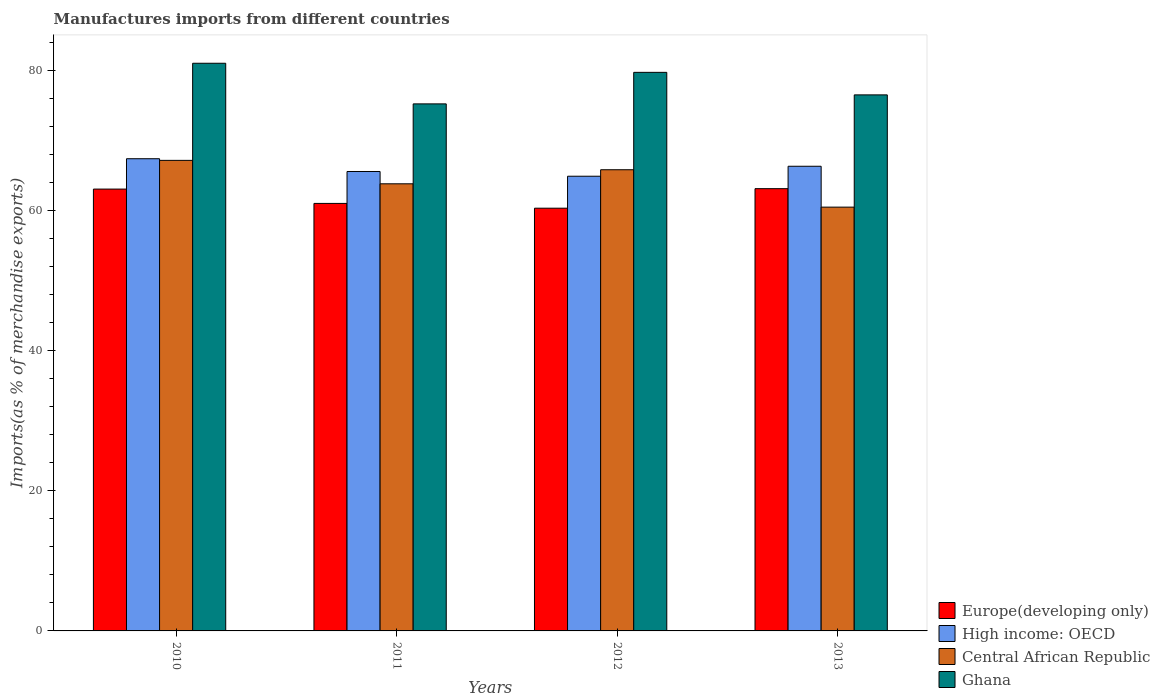How many different coloured bars are there?
Offer a very short reply. 4. How many bars are there on the 2nd tick from the left?
Provide a succinct answer. 4. How many bars are there on the 3rd tick from the right?
Give a very brief answer. 4. In how many cases, is the number of bars for a given year not equal to the number of legend labels?
Your answer should be compact. 0. What is the percentage of imports to different countries in High income: OECD in 2013?
Ensure brevity in your answer.  66.35. Across all years, what is the maximum percentage of imports to different countries in High income: OECD?
Ensure brevity in your answer.  67.43. Across all years, what is the minimum percentage of imports to different countries in High income: OECD?
Make the answer very short. 64.93. In which year was the percentage of imports to different countries in Central African Republic maximum?
Make the answer very short. 2010. In which year was the percentage of imports to different countries in High income: OECD minimum?
Your answer should be very brief. 2012. What is the total percentage of imports to different countries in Ghana in the graph?
Make the answer very short. 312.63. What is the difference between the percentage of imports to different countries in High income: OECD in 2010 and that in 2012?
Offer a terse response. 2.5. What is the difference between the percentage of imports to different countries in Central African Republic in 2012 and the percentage of imports to different countries in High income: OECD in 2013?
Provide a short and direct response. -0.5. What is the average percentage of imports to different countries in Central African Republic per year?
Ensure brevity in your answer.  64.35. In the year 2011, what is the difference between the percentage of imports to different countries in High income: OECD and percentage of imports to different countries in Europe(developing only)?
Keep it short and to the point. 4.56. What is the ratio of the percentage of imports to different countries in Central African Republic in 2010 to that in 2012?
Provide a succinct answer. 1.02. What is the difference between the highest and the second highest percentage of imports to different countries in Central African Republic?
Ensure brevity in your answer.  1.34. What is the difference between the highest and the lowest percentage of imports to different countries in Ghana?
Your answer should be compact. 5.8. What does the 2nd bar from the left in 2011 represents?
Provide a short and direct response. High income: OECD. What does the 3rd bar from the right in 2010 represents?
Keep it short and to the point. High income: OECD. Are all the bars in the graph horizontal?
Provide a short and direct response. No. What is the difference between two consecutive major ticks on the Y-axis?
Make the answer very short. 20. Where does the legend appear in the graph?
Ensure brevity in your answer.  Bottom right. How are the legend labels stacked?
Your answer should be compact. Vertical. What is the title of the graph?
Offer a terse response. Manufactures imports from different countries. What is the label or title of the X-axis?
Your answer should be very brief. Years. What is the label or title of the Y-axis?
Give a very brief answer. Imports(as % of merchandise exports). What is the Imports(as % of merchandise exports) in Europe(developing only) in 2010?
Provide a succinct answer. 63.09. What is the Imports(as % of merchandise exports) of High income: OECD in 2010?
Your answer should be very brief. 67.43. What is the Imports(as % of merchandise exports) in Central African Republic in 2010?
Provide a short and direct response. 67.19. What is the Imports(as % of merchandise exports) in Ghana in 2010?
Your response must be concise. 81.06. What is the Imports(as % of merchandise exports) of Europe(developing only) in 2011?
Give a very brief answer. 61.05. What is the Imports(as % of merchandise exports) in High income: OECD in 2011?
Your response must be concise. 65.6. What is the Imports(as % of merchandise exports) of Central African Republic in 2011?
Offer a very short reply. 63.85. What is the Imports(as % of merchandise exports) of Ghana in 2011?
Give a very brief answer. 75.26. What is the Imports(as % of merchandise exports) of Europe(developing only) in 2012?
Ensure brevity in your answer.  60.36. What is the Imports(as % of merchandise exports) in High income: OECD in 2012?
Give a very brief answer. 64.93. What is the Imports(as % of merchandise exports) of Central African Republic in 2012?
Your response must be concise. 65.86. What is the Imports(as % of merchandise exports) in Ghana in 2012?
Offer a very short reply. 79.76. What is the Imports(as % of merchandise exports) in Europe(developing only) in 2013?
Your answer should be very brief. 63.15. What is the Imports(as % of merchandise exports) in High income: OECD in 2013?
Make the answer very short. 66.35. What is the Imports(as % of merchandise exports) in Central African Republic in 2013?
Make the answer very short. 60.52. What is the Imports(as % of merchandise exports) of Ghana in 2013?
Your answer should be very brief. 76.55. Across all years, what is the maximum Imports(as % of merchandise exports) of Europe(developing only)?
Give a very brief answer. 63.15. Across all years, what is the maximum Imports(as % of merchandise exports) of High income: OECD?
Your answer should be compact. 67.43. Across all years, what is the maximum Imports(as % of merchandise exports) in Central African Republic?
Your answer should be very brief. 67.19. Across all years, what is the maximum Imports(as % of merchandise exports) in Ghana?
Keep it short and to the point. 81.06. Across all years, what is the minimum Imports(as % of merchandise exports) in Europe(developing only)?
Provide a short and direct response. 60.36. Across all years, what is the minimum Imports(as % of merchandise exports) in High income: OECD?
Your answer should be compact. 64.93. Across all years, what is the minimum Imports(as % of merchandise exports) of Central African Republic?
Offer a very short reply. 60.52. Across all years, what is the minimum Imports(as % of merchandise exports) of Ghana?
Provide a succinct answer. 75.26. What is the total Imports(as % of merchandise exports) of Europe(developing only) in the graph?
Offer a terse response. 247.66. What is the total Imports(as % of merchandise exports) of High income: OECD in the graph?
Your answer should be very brief. 264.32. What is the total Imports(as % of merchandise exports) in Central African Republic in the graph?
Your response must be concise. 257.41. What is the total Imports(as % of merchandise exports) of Ghana in the graph?
Make the answer very short. 312.63. What is the difference between the Imports(as % of merchandise exports) in Europe(developing only) in 2010 and that in 2011?
Provide a succinct answer. 2.05. What is the difference between the Imports(as % of merchandise exports) of High income: OECD in 2010 and that in 2011?
Your response must be concise. 1.82. What is the difference between the Imports(as % of merchandise exports) in Central African Republic in 2010 and that in 2011?
Make the answer very short. 3.35. What is the difference between the Imports(as % of merchandise exports) of Ghana in 2010 and that in 2011?
Offer a terse response. 5.8. What is the difference between the Imports(as % of merchandise exports) in Europe(developing only) in 2010 and that in 2012?
Keep it short and to the point. 2.73. What is the difference between the Imports(as % of merchandise exports) of High income: OECD in 2010 and that in 2012?
Offer a terse response. 2.5. What is the difference between the Imports(as % of merchandise exports) in Central African Republic in 2010 and that in 2012?
Offer a very short reply. 1.34. What is the difference between the Imports(as % of merchandise exports) of Ghana in 2010 and that in 2012?
Provide a succinct answer. 1.3. What is the difference between the Imports(as % of merchandise exports) of Europe(developing only) in 2010 and that in 2013?
Your response must be concise. -0.06. What is the difference between the Imports(as % of merchandise exports) in High income: OECD in 2010 and that in 2013?
Your answer should be compact. 1.07. What is the difference between the Imports(as % of merchandise exports) of Central African Republic in 2010 and that in 2013?
Offer a very short reply. 6.68. What is the difference between the Imports(as % of merchandise exports) in Ghana in 2010 and that in 2013?
Provide a short and direct response. 4.52. What is the difference between the Imports(as % of merchandise exports) of Europe(developing only) in 2011 and that in 2012?
Your answer should be compact. 0.68. What is the difference between the Imports(as % of merchandise exports) in High income: OECD in 2011 and that in 2012?
Your answer should be compact. 0.68. What is the difference between the Imports(as % of merchandise exports) of Central African Republic in 2011 and that in 2012?
Make the answer very short. -2.01. What is the difference between the Imports(as % of merchandise exports) of Ghana in 2011 and that in 2012?
Your answer should be compact. -4.5. What is the difference between the Imports(as % of merchandise exports) of Europe(developing only) in 2011 and that in 2013?
Give a very brief answer. -2.1. What is the difference between the Imports(as % of merchandise exports) in High income: OECD in 2011 and that in 2013?
Your answer should be very brief. -0.75. What is the difference between the Imports(as % of merchandise exports) in Central African Republic in 2011 and that in 2013?
Provide a short and direct response. 3.33. What is the difference between the Imports(as % of merchandise exports) of Ghana in 2011 and that in 2013?
Provide a short and direct response. -1.29. What is the difference between the Imports(as % of merchandise exports) of Europe(developing only) in 2012 and that in 2013?
Give a very brief answer. -2.79. What is the difference between the Imports(as % of merchandise exports) of High income: OECD in 2012 and that in 2013?
Provide a short and direct response. -1.42. What is the difference between the Imports(as % of merchandise exports) of Central African Republic in 2012 and that in 2013?
Offer a terse response. 5.34. What is the difference between the Imports(as % of merchandise exports) in Ghana in 2012 and that in 2013?
Provide a succinct answer. 3.22. What is the difference between the Imports(as % of merchandise exports) in Europe(developing only) in 2010 and the Imports(as % of merchandise exports) in High income: OECD in 2011?
Your answer should be compact. -2.51. What is the difference between the Imports(as % of merchandise exports) of Europe(developing only) in 2010 and the Imports(as % of merchandise exports) of Central African Republic in 2011?
Provide a succinct answer. -0.75. What is the difference between the Imports(as % of merchandise exports) of Europe(developing only) in 2010 and the Imports(as % of merchandise exports) of Ghana in 2011?
Give a very brief answer. -12.17. What is the difference between the Imports(as % of merchandise exports) of High income: OECD in 2010 and the Imports(as % of merchandise exports) of Central African Republic in 2011?
Your answer should be very brief. 3.58. What is the difference between the Imports(as % of merchandise exports) of High income: OECD in 2010 and the Imports(as % of merchandise exports) of Ghana in 2011?
Your answer should be compact. -7.83. What is the difference between the Imports(as % of merchandise exports) in Central African Republic in 2010 and the Imports(as % of merchandise exports) in Ghana in 2011?
Give a very brief answer. -8.07. What is the difference between the Imports(as % of merchandise exports) of Europe(developing only) in 2010 and the Imports(as % of merchandise exports) of High income: OECD in 2012?
Offer a very short reply. -1.84. What is the difference between the Imports(as % of merchandise exports) in Europe(developing only) in 2010 and the Imports(as % of merchandise exports) in Central African Republic in 2012?
Offer a terse response. -2.76. What is the difference between the Imports(as % of merchandise exports) in Europe(developing only) in 2010 and the Imports(as % of merchandise exports) in Ghana in 2012?
Offer a very short reply. -16.67. What is the difference between the Imports(as % of merchandise exports) in High income: OECD in 2010 and the Imports(as % of merchandise exports) in Central African Republic in 2012?
Your answer should be very brief. 1.57. What is the difference between the Imports(as % of merchandise exports) of High income: OECD in 2010 and the Imports(as % of merchandise exports) of Ghana in 2012?
Ensure brevity in your answer.  -12.33. What is the difference between the Imports(as % of merchandise exports) in Central African Republic in 2010 and the Imports(as % of merchandise exports) in Ghana in 2012?
Provide a short and direct response. -12.57. What is the difference between the Imports(as % of merchandise exports) of Europe(developing only) in 2010 and the Imports(as % of merchandise exports) of High income: OECD in 2013?
Your answer should be very brief. -3.26. What is the difference between the Imports(as % of merchandise exports) of Europe(developing only) in 2010 and the Imports(as % of merchandise exports) of Central African Republic in 2013?
Offer a terse response. 2.58. What is the difference between the Imports(as % of merchandise exports) of Europe(developing only) in 2010 and the Imports(as % of merchandise exports) of Ghana in 2013?
Give a very brief answer. -13.45. What is the difference between the Imports(as % of merchandise exports) of High income: OECD in 2010 and the Imports(as % of merchandise exports) of Central African Republic in 2013?
Make the answer very short. 6.91. What is the difference between the Imports(as % of merchandise exports) in High income: OECD in 2010 and the Imports(as % of merchandise exports) in Ghana in 2013?
Your answer should be compact. -9.12. What is the difference between the Imports(as % of merchandise exports) of Central African Republic in 2010 and the Imports(as % of merchandise exports) of Ghana in 2013?
Your answer should be very brief. -9.35. What is the difference between the Imports(as % of merchandise exports) in Europe(developing only) in 2011 and the Imports(as % of merchandise exports) in High income: OECD in 2012?
Provide a short and direct response. -3.88. What is the difference between the Imports(as % of merchandise exports) of Europe(developing only) in 2011 and the Imports(as % of merchandise exports) of Central African Republic in 2012?
Give a very brief answer. -4.81. What is the difference between the Imports(as % of merchandise exports) of Europe(developing only) in 2011 and the Imports(as % of merchandise exports) of Ghana in 2012?
Your response must be concise. -18.71. What is the difference between the Imports(as % of merchandise exports) in High income: OECD in 2011 and the Imports(as % of merchandise exports) in Central African Republic in 2012?
Your response must be concise. -0.25. What is the difference between the Imports(as % of merchandise exports) of High income: OECD in 2011 and the Imports(as % of merchandise exports) of Ghana in 2012?
Keep it short and to the point. -14.16. What is the difference between the Imports(as % of merchandise exports) of Central African Republic in 2011 and the Imports(as % of merchandise exports) of Ghana in 2012?
Your answer should be compact. -15.91. What is the difference between the Imports(as % of merchandise exports) of Europe(developing only) in 2011 and the Imports(as % of merchandise exports) of High income: OECD in 2013?
Your answer should be very brief. -5.31. What is the difference between the Imports(as % of merchandise exports) in Europe(developing only) in 2011 and the Imports(as % of merchandise exports) in Central African Republic in 2013?
Provide a succinct answer. 0.53. What is the difference between the Imports(as % of merchandise exports) of Europe(developing only) in 2011 and the Imports(as % of merchandise exports) of Ghana in 2013?
Give a very brief answer. -15.5. What is the difference between the Imports(as % of merchandise exports) of High income: OECD in 2011 and the Imports(as % of merchandise exports) of Central African Republic in 2013?
Your answer should be very brief. 5.09. What is the difference between the Imports(as % of merchandise exports) of High income: OECD in 2011 and the Imports(as % of merchandise exports) of Ghana in 2013?
Provide a succinct answer. -10.94. What is the difference between the Imports(as % of merchandise exports) in Central African Republic in 2011 and the Imports(as % of merchandise exports) in Ghana in 2013?
Give a very brief answer. -12.7. What is the difference between the Imports(as % of merchandise exports) of Europe(developing only) in 2012 and the Imports(as % of merchandise exports) of High income: OECD in 2013?
Give a very brief answer. -5.99. What is the difference between the Imports(as % of merchandise exports) of Europe(developing only) in 2012 and the Imports(as % of merchandise exports) of Central African Republic in 2013?
Provide a short and direct response. -0.15. What is the difference between the Imports(as % of merchandise exports) of Europe(developing only) in 2012 and the Imports(as % of merchandise exports) of Ghana in 2013?
Offer a very short reply. -16.18. What is the difference between the Imports(as % of merchandise exports) of High income: OECD in 2012 and the Imports(as % of merchandise exports) of Central African Republic in 2013?
Make the answer very short. 4.41. What is the difference between the Imports(as % of merchandise exports) in High income: OECD in 2012 and the Imports(as % of merchandise exports) in Ghana in 2013?
Ensure brevity in your answer.  -11.62. What is the difference between the Imports(as % of merchandise exports) of Central African Republic in 2012 and the Imports(as % of merchandise exports) of Ghana in 2013?
Your response must be concise. -10.69. What is the average Imports(as % of merchandise exports) of Europe(developing only) per year?
Keep it short and to the point. 61.91. What is the average Imports(as % of merchandise exports) in High income: OECD per year?
Your answer should be very brief. 66.08. What is the average Imports(as % of merchandise exports) of Central African Republic per year?
Offer a terse response. 64.35. What is the average Imports(as % of merchandise exports) in Ghana per year?
Keep it short and to the point. 78.16. In the year 2010, what is the difference between the Imports(as % of merchandise exports) in Europe(developing only) and Imports(as % of merchandise exports) in High income: OECD?
Offer a very short reply. -4.33. In the year 2010, what is the difference between the Imports(as % of merchandise exports) in Europe(developing only) and Imports(as % of merchandise exports) in Central African Republic?
Give a very brief answer. -4.1. In the year 2010, what is the difference between the Imports(as % of merchandise exports) of Europe(developing only) and Imports(as % of merchandise exports) of Ghana?
Offer a very short reply. -17.97. In the year 2010, what is the difference between the Imports(as % of merchandise exports) in High income: OECD and Imports(as % of merchandise exports) in Central African Republic?
Your response must be concise. 0.23. In the year 2010, what is the difference between the Imports(as % of merchandise exports) of High income: OECD and Imports(as % of merchandise exports) of Ghana?
Your answer should be very brief. -13.63. In the year 2010, what is the difference between the Imports(as % of merchandise exports) in Central African Republic and Imports(as % of merchandise exports) in Ghana?
Give a very brief answer. -13.87. In the year 2011, what is the difference between the Imports(as % of merchandise exports) in Europe(developing only) and Imports(as % of merchandise exports) in High income: OECD?
Ensure brevity in your answer.  -4.56. In the year 2011, what is the difference between the Imports(as % of merchandise exports) in Europe(developing only) and Imports(as % of merchandise exports) in Central African Republic?
Ensure brevity in your answer.  -2.8. In the year 2011, what is the difference between the Imports(as % of merchandise exports) in Europe(developing only) and Imports(as % of merchandise exports) in Ghana?
Provide a succinct answer. -14.21. In the year 2011, what is the difference between the Imports(as % of merchandise exports) of High income: OECD and Imports(as % of merchandise exports) of Central African Republic?
Keep it short and to the point. 1.76. In the year 2011, what is the difference between the Imports(as % of merchandise exports) of High income: OECD and Imports(as % of merchandise exports) of Ghana?
Your answer should be very brief. -9.66. In the year 2011, what is the difference between the Imports(as % of merchandise exports) of Central African Republic and Imports(as % of merchandise exports) of Ghana?
Make the answer very short. -11.41. In the year 2012, what is the difference between the Imports(as % of merchandise exports) of Europe(developing only) and Imports(as % of merchandise exports) of High income: OECD?
Make the answer very short. -4.56. In the year 2012, what is the difference between the Imports(as % of merchandise exports) in Europe(developing only) and Imports(as % of merchandise exports) in Central African Republic?
Your response must be concise. -5.49. In the year 2012, what is the difference between the Imports(as % of merchandise exports) of Europe(developing only) and Imports(as % of merchandise exports) of Ghana?
Your response must be concise. -19.4. In the year 2012, what is the difference between the Imports(as % of merchandise exports) in High income: OECD and Imports(as % of merchandise exports) in Central African Republic?
Keep it short and to the point. -0.93. In the year 2012, what is the difference between the Imports(as % of merchandise exports) of High income: OECD and Imports(as % of merchandise exports) of Ghana?
Ensure brevity in your answer.  -14.83. In the year 2012, what is the difference between the Imports(as % of merchandise exports) in Central African Republic and Imports(as % of merchandise exports) in Ghana?
Your response must be concise. -13.91. In the year 2013, what is the difference between the Imports(as % of merchandise exports) of Europe(developing only) and Imports(as % of merchandise exports) of High income: OECD?
Offer a very short reply. -3.2. In the year 2013, what is the difference between the Imports(as % of merchandise exports) in Europe(developing only) and Imports(as % of merchandise exports) in Central African Republic?
Your answer should be very brief. 2.64. In the year 2013, what is the difference between the Imports(as % of merchandise exports) of Europe(developing only) and Imports(as % of merchandise exports) of Ghana?
Provide a short and direct response. -13.39. In the year 2013, what is the difference between the Imports(as % of merchandise exports) of High income: OECD and Imports(as % of merchandise exports) of Central African Republic?
Make the answer very short. 5.84. In the year 2013, what is the difference between the Imports(as % of merchandise exports) of High income: OECD and Imports(as % of merchandise exports) of Ghana?
Your response must be concise. -10.19. In the year 2013, what is the difference between the Imports(as % of merchandise exports) of Central African Republic and Imports(as % of merchandise exports) of Ghana?
Provide a succinct answer. -16.03. What is the ratio of the Imports(as % of merchandise exports) in Europe(developing only) in 2010 to that in 2011?
Offer a very short reply. 1.03. What is the ratio of the Imports(as % of merchandise exports) of High income: OECD in 2010 to that in 2011?
Provide a succinct answer. 1.03. What is the ratio of the Imports(as % of merchandise exports) in Central African Republic in 2010 to that in 2011?
Keep it short and to the point. 1.05. What is the ratio of the Imports(as % of merchandise exports) in Ghana in 2010 to that in 2011?
Keep it short and to the point. 1.08. What is the ratio of the Imports(as % of merchandise exports) in Europe(developing only) in 2010 to that in 2012?
Offer a terse response. 1.05. What is the ratio of the Imports(as % of merchandise exports) of Central African Republic in 2010 to that in 2012?
Offer a terse response. 1.02. What is the ratio of the Imports(as % of merchandise exports) of Ghana in 2010 to that in 2012?
Make the answer very short. 1.02. What is the ratio of the Imports(as % of merchandise exports) of High income: OECD in 2010 to that in 2013?
Offer a terse response. 1.02. What is the ratio of the Imports(as % of merchandise exports) of Central African Republic in 2010 to that in 2013?
Your response must be concise. 1.11. What is the ratio of the Imports(as % of merchandise exports) of Ghana in 2010 to that in 2013?
Provide a short and direct response. 1.06. What is the ratio of the Imports(as % of merchandise exports) in Europe(developing only) in 2011 to that in 2012?
Make the answer very short. 1.01. What is the ratio of the Imports(as % of merchandise exports) in High income: OECD in 2011 to that in 2012?
Your response must be concise. 1.01. What is the ratio of the Imports(as % of merchandise exports) of Central African Republic in 2011 to that in 2012?
Provide a succinct answer. 0.97. What is the ratio of the Imports(as % of merchandise exports) of Ghana in 2011 to that in 2012?
Offer a terse response. 0.94. What is the ratio of the Imports(as % of merchandise exports) of Europe(developing only) in 2011 to that in 2013?
Keep it short and to the point. 0.97. What is the ratio of the Imports(as % of merchandise exports) of High income: OECD in 2011 to that in 2013?
Give a very brief answer. 0.99. What is the ratio of the Imports(as % of merchandise exports) in Central African Republic in 2011 to that in 2013?
Keep it short and to the point. 1.06. What is the ratio of the Imports(as % of merchandise exports) in Ghana in 2011 to that in 2013?
Provide a short and direct response. 0.98. What is the ratio of the Imports(as % of merchandise exports) of Europe(developing only) in 2012 to that in 2013?
Ensure brevity in your answer.  0.96. What is the ratio of the Imports(as % of merchandise exports) of High income: OECD in 2012 to that in 2013?
Make the answer very short. 0.98. What is the ratio of the Imports(as % of merchandise exports) of Central African Republic in 2012 to that in 2013?
Your response must be concise. 1.09. What is the ratio of the Imports(as % of merchandise exports) of Ghana in 2012 to that in 2013?
Make the answer very short. 1.04. What is the difference between the highest and the second highest Imports(as % of merchandise exports) in Europe(developing only)?
Your response must be concise. 0.06. What is the difference between the highest and the second highest Imports(as % of merchandise exports) in High income: OECD?
Your answer should be very brief. 1.07. What is the difference between the highest and the second highest Imports(as % of merchandise exports) in Central African Republic?
Your answer should be very brief. 1.34. What is the difference between the highest and the second highest Imports(as % of merchandise exports) of Ghana?
Ensure brevity in your answer.  1.3. What is the difference between the highest and the lowest Imports(as % of merchandise exports) of Europe(developing only)?
Offer a very short reply. 2.79. What is the difference between the highest and the lowest Imports(as % of merchandise exports) of High income: OECD?
Provide a succinct answer. 2.5. What is the difference between the highest and the lowest Imports(as % of merchandise exports) in Central African Republic?
Ensure brevity in your answer.  6.68. What is the difference between the highest and the lowest Imports(as % of merchandise exports) of Ghana?
Give a very brief answer. 5.8. 